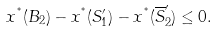Convert formula to latex. <formula><loc_0><loc_0><loc_500><loc_500>x ^ { ^ { * } } ( B _ { 2 } ) - x ^ { ^ { * } } ( S _ { 1 } ^ { \prime } ) - x ^ { ^ { * } } ( \overline { S } _ { 2 } ^ { \prime } ) \leq 0 .</formula> 